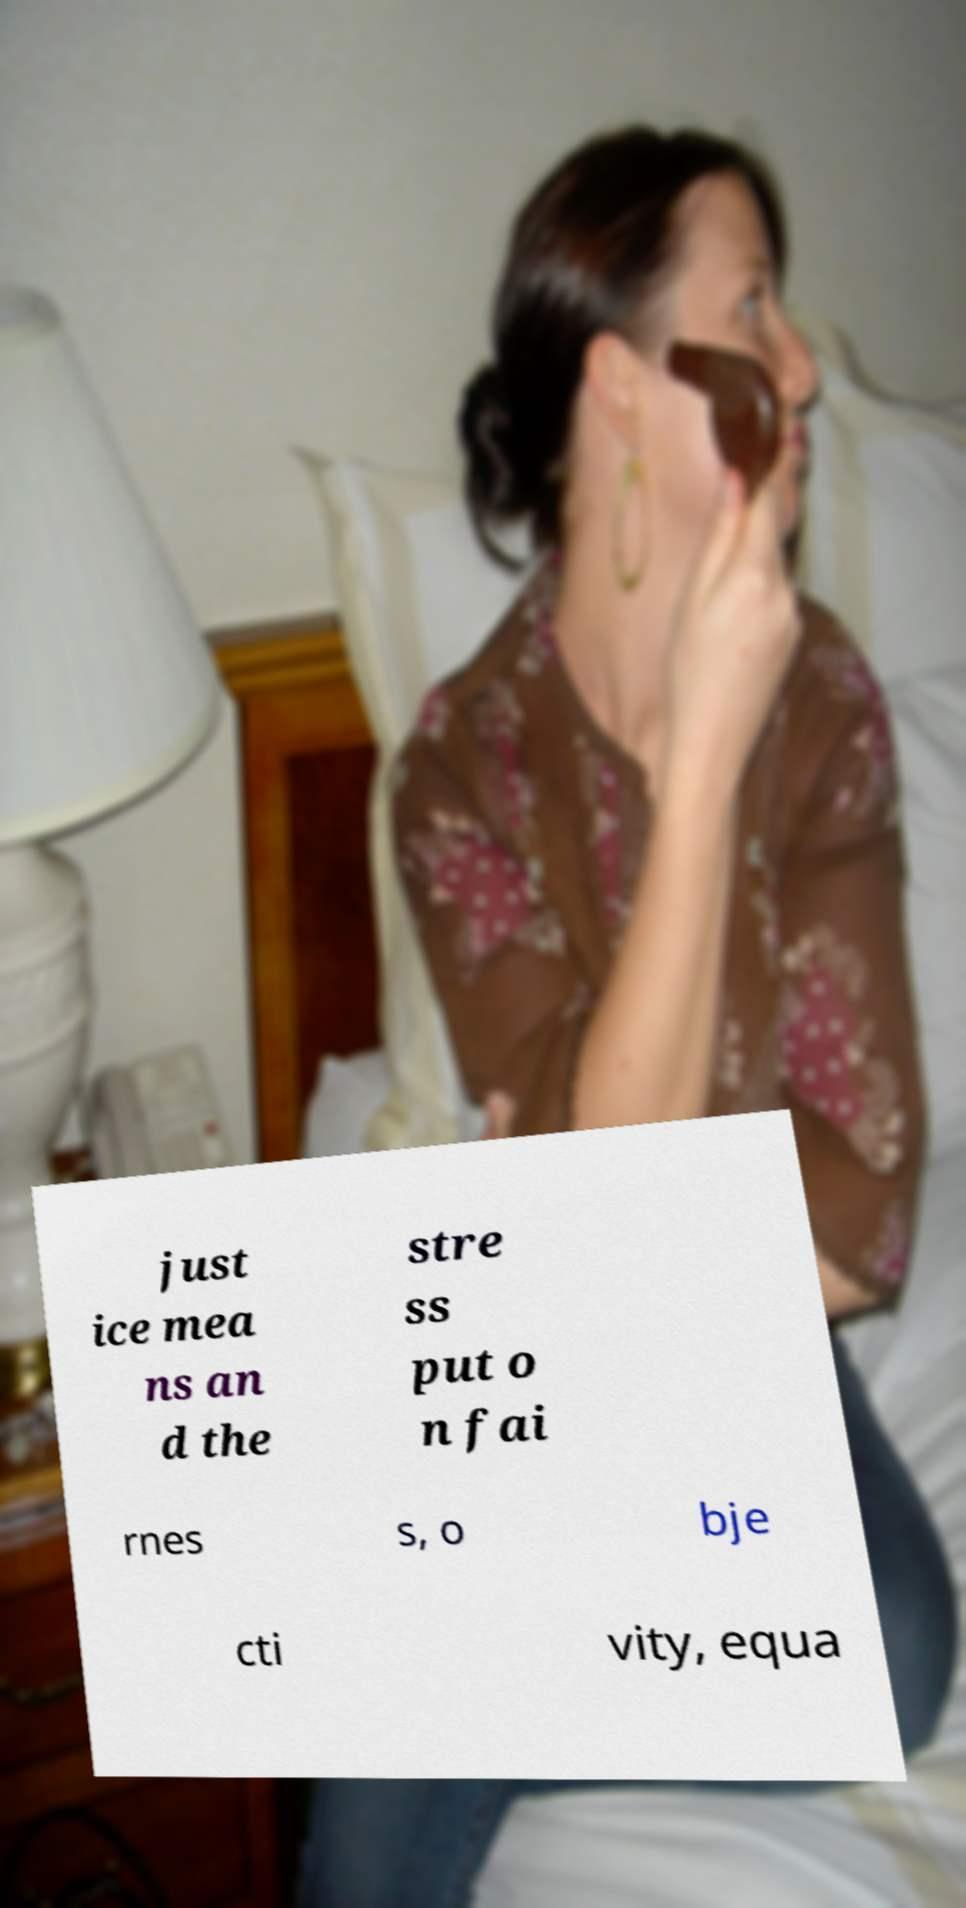There's text embedded in this image that I need extracted. Can you transcribe it verbatim? just ice mea ns an d the stre ss put o n fai rnes s, o bje cti vity, equa 